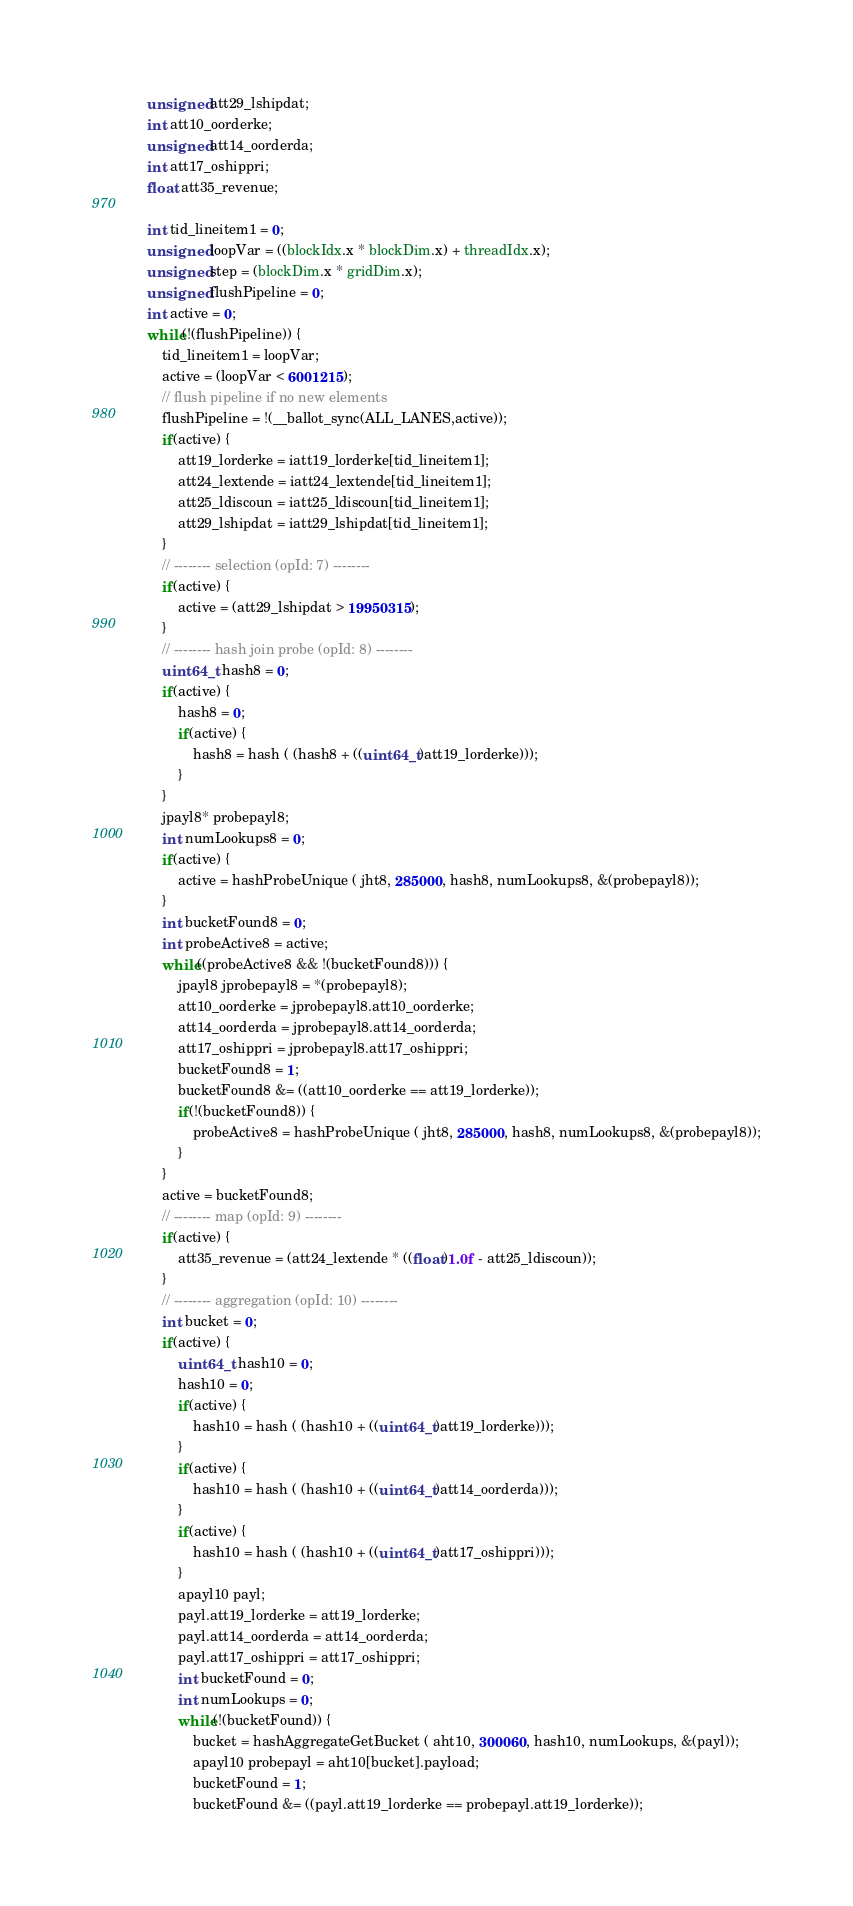Convert code to text. <code><loc_0><loc_0><loc_500><loc_500><_Cuda_>    unsigned att29_lshipdat;
    int att10_oorderke;
    unsigned att14_oorderda;
    int att17_oshippri;
    float att35_revenue;

    int tid_lineitem1 = 0;
    unsigned loopVar = ((blockIdx.x * blockDim.x) + threadIdx.x);
    unsigned step = (blockDim.x * gridDim.x);
    unsigned flushPipeline = 0;
    int active = 0;
    while(!(flushPipeline)) {
        tid_lineitem1 = loopVar;
        active = (loopVar < 6001215);
        // flush pipeline if no new elements
        flushPipeline = !(__ballot_sync(ALL_LANES,active));
        if(active) {
            att19_lorderke = iatt19_lorderke[tid_lineitem1];
            att24_lextende = iatt24_lextende[tid_lineitem1];
            att25_ldiscoun = iatt25_ldiscoun[tid_lineitem1];
            att29_lshipdat = iatt29_lshipdat[tid_lineitem1];
        }
        // -------- selection (opId: 7) --------
        if(active) {
            active = (att29_lshipdat > 19950315);
        }
        // -------- hash join probe (opId: 8) --------
        uint64_t hash8 = 0;
        if(active) {
            hash8 = 0;
            if(active) {
                hash8 = hash ( (hash8 + ((uint64_t)att19_lorderke)));
            }
        }
        jpayl8* probepayl8;
        int numLookups8 = 0;
        if(active) {
            active = hashProbeUnique ( jht8, 285000, hash8, numLookups8, &(probepayl8));
        }
        int bucketFound8 = 0;
        int probeActive8 = active;
        while((probeActive8 && !(bucketFound8))) {
            jpayl8 jprobepayl8 = *(probepayl8);
            att10_oorderke = jprobepayl8.att10_oorderke;
            att14_oorderda = jprobepayl8.att14_oorderda;
            att17_oshippri = jprobepayl8.att17_oshippri;
            bucketFound8 = 1;
            bucketFound8 &= ((att10_oorderke == att19_lorderke));
            if(!(bucketFound8)) {
                probeActive8 = hashProbeUnique ( jht8, 285000, hash8, numLookups8, &(probepayl8));
            }
        }
        active = bucketFound8;
        // -------- map (opId: 9) --------
        if(active) {
            att35_revenue = (att24_lextende * ((float)1.0f - att25_ldiscoun));
        }
        // -------- aggregation (opId: 10) --------
        int bucket = 0;
        if(active) {
            uint64_t hash10 = 0;
            hash10 = 0;
            if(active) {
                hash10 = hash ( (hash10 + ((uint64_t)att19_lorderke)));
            }
            if(active) {
                hash10 = hash ( (hash10 + ((uint64_t)att14_oorderda)));
            }
            if(active) {
                hash10 = hash ( (hash10 + ((uint64_t)att17_oshippri)));
            }
            apayl10 payl;
            payl.att19_lorderke = att19_lorderke;
            payl.att14_oorderda = att14_oorderda;
            payl.att17_oshippri = att17_oshippri;
            int bucketFound = 0;
            int numLookups = 0;
            while(!(bucketFound)) {
                bucket = hashAggregateGetBucket ( aht10, 300060, hash10, numLookups, &(payl));
                apayl10 probepayl = aht10[bucket].payload;
                bucketFound = 1;
                bucketFound &= ((payl.att19_lorderke == probepayl.att19_lorderke));</code> 